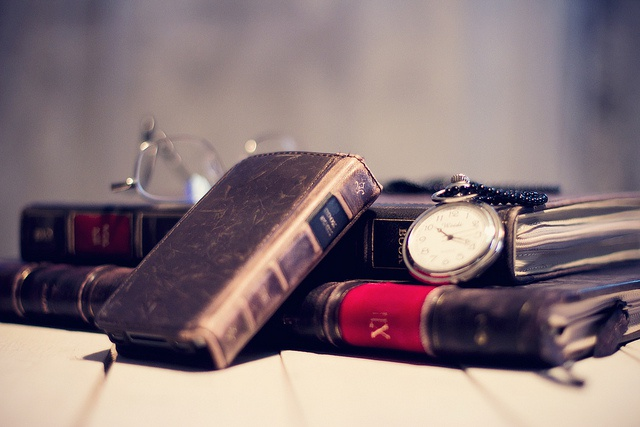Describe the objects in this image and their specific colors. I can see book in navy, purple, and black tones, book in navy, black, purple, and brown tones, book in navy, black, gray, darkgray, and purple tones, clock in navy, beige, gray, and tan tones, and book in navy, black, purple, and brown tones in this image. 